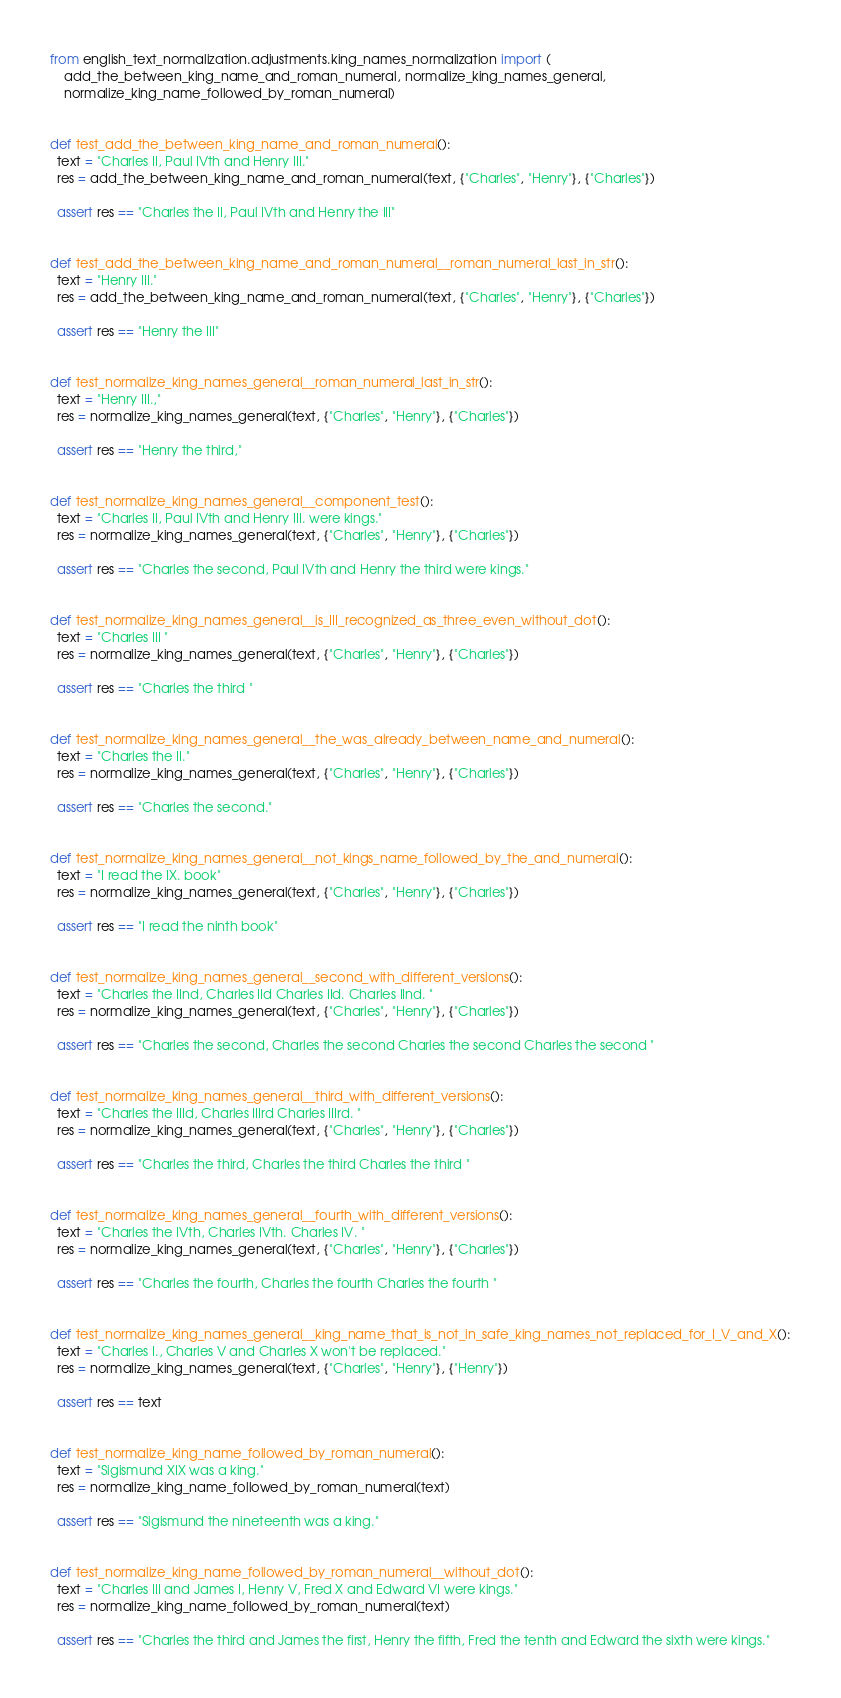<code> <loc_0><loc_0><loc_500><loc_500><_Python_>from english_text_normalization.adjustments.king_names_normalization import (
    add_the_between_king_name_and_roman_numeral, normalize_king_names_general,
    normalize_king_name_followed_by_roman_numeral)


def test_add_the_between_king_name_and_roman_numeral():
  text = "Charles II, Paul IVth and Henry III."
  res = add_the_between_king_name_and_roman_numeral(text, {"Charles", "Henry"}, {"Charles"})

  assert res == "Charles the II, Paul IVth and Henry the III"


def test_add_the_between_king_name_and_roman_numeral__roman_numeral_last_in_str():
  text = "Henry III."
  res = add_the_between_king_name_and_roman_numeral(text, {"Charles", "Henry"}, {"Charles"})

  assert res == "Henry the III"


def test_normalize_king_names_general__roman_numeral_last_in_str():
  text = "Henry III.,"
  res = normalize_king_names_general(text, {"Charles", "Henry"}, {"Charles"})

  assert res == "Henry the third,"


def test_normalize_king_names_general__component_test():
  text = "Charles II, Paul IVth and Henry III. were kings."
  res = normalize_king_names_general(text, {"Charles", "Henry"}, {"Charles"})

  assert res == "Charles the second, Paul IVth and Henry the third were kings."


def test_normalize_king_names_general__is_III_recognized_as_three_even_without_dot():
  text = "Charles III "
  res = normalize_king_names_general(text, {"Charles", "Henry"}, {"Charles"})

  assert res == "Charles the third "


def test_normalize_king_names_general__the_was_already_between_name_and_numeral():
  text = "Charles the II."
  res = normalize_king_names_general(text, {"Charles", "Henry"}, {"Charles"})

  assert res == "Charles the second."


def test_normalize_king_names_general__not_kings_name_followed_by_the_and_numeral():
  text = "I read the IX. book"
  res = normalize_king_names_general(text, {"Charles", "Henry"}, {"Charles"})

  assert res == "I read the ninth book"


def test_normalize_king_names_general__second_with_different_versions():
  text = "Charles the IInd, Charles IId Charles IId. Charles IInd. "
  res = normalize_king_names_general(text, {"Charles", "Henry"}, {"Charles"})

  assert res == "Charles the second, Charles the second Charles the second Charles the second "


def test_normalize_king_names_general__third_with_different_versions():
  text = "Charles the IIId, Charles IIIrd Charles IIIrd. "
  res = normalize_king_names_general(text, {"Charles", "Henry"}, {"Charles"})

  assert res == "Charles the third, Charles the third Charles the third "


def test_normalize_king_names_general__fourth_with_different_versions():
  text = "Charles the IVth, Charles IVth. Charles IV. "
  res = normalize_king_names_general(text, {"Charles", "Henry"}, {"Charles"})

  assert res == "Charles the fourth, Charles the fourth Charles the fourth "


def test_normalize_king_names_general__king_name_that_is_not_in_safe_king_names_not_replaced_for_I_V_and_X():
  text = "Charles I., Charles V and Charles X won't be replaced."
  res = normalize_king_names_general(text, {"Charles", "Henry"}, {"Henry"})

  assert res == text


def test_normalize_king_name_followed_by_roman_numeral():
  text = "Sigismund XIX was a king."
  res = normalize_king_name_followed_by_roman_numeral(text)

  assert res == "Sigismund the nineteenth was a king."


def test_normalize_king_name_followed_by_roman_numeral__without_dot():
  text = "Charles III and James I, Henry V, Fred X and Edward VI were kings."
  res = normalize_king_name_followed_by_roman_numeral(text)

  assert res == "Charles the third and James the first, Henry the fifth, Fred the tenth and Edward the sixth were kings."
</code> 